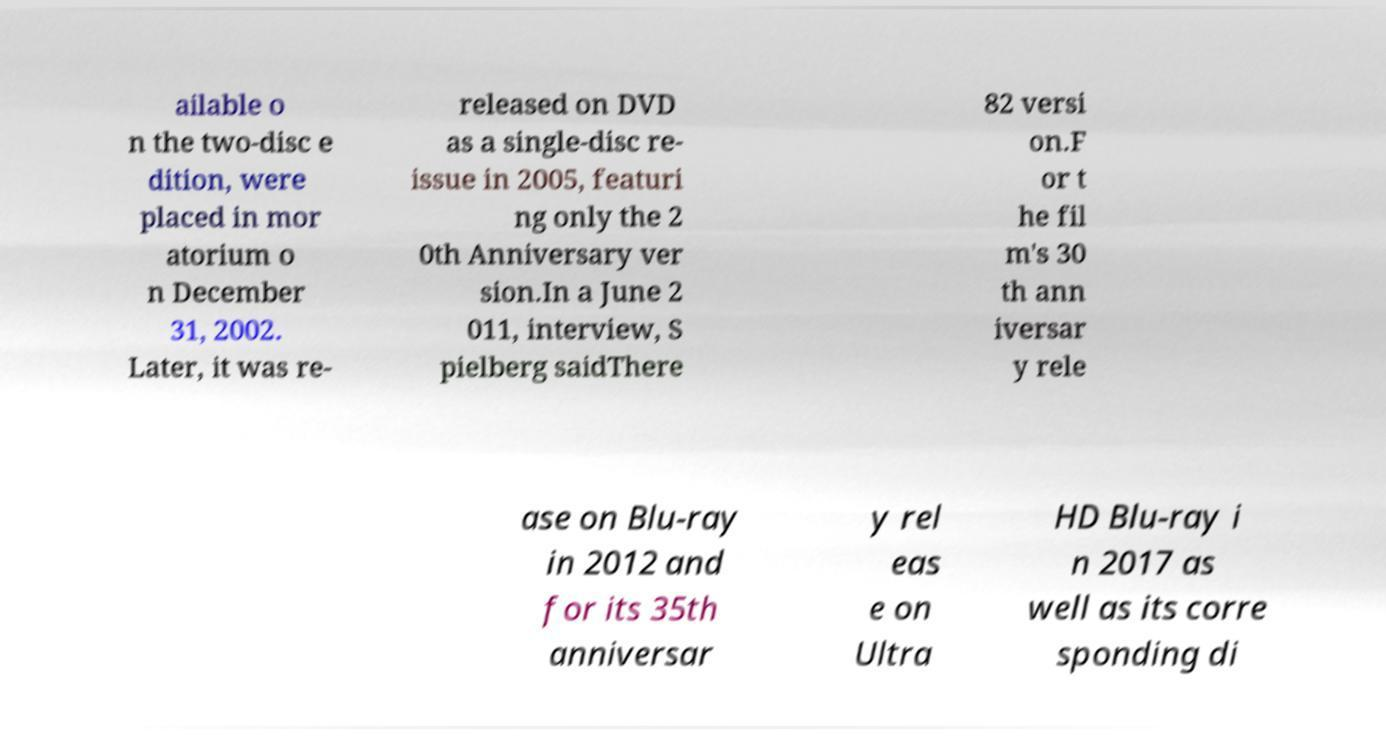Can you read and provide the text displayed in the image?This photo seems to have some interesting text. Can you extract and type it out for me? ailable o n the two-disc e dition, were placed in mor atorium o n December 31, 2002. Later, it was re- released on DVD as a single-disc re- issue in 2005, featuri ng only the 2 0th Anniversary ver sion.In a June 2 011, interview, S pielberg saidThere 82 versi on.F or t he fil m's 30 th ann iversar y rele ase on Blu-ray in 2012 and for its 35th anniversar y rel eas e on Ultra HD Blu-ray i n 2017 as well as its corre sponding di 